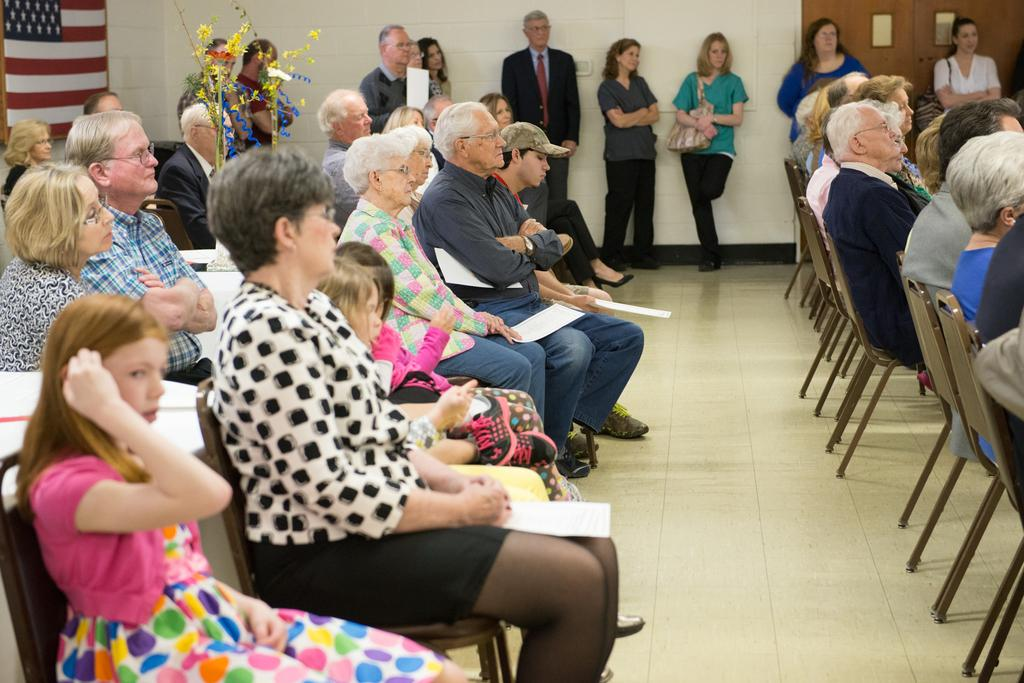What are the people in the image doing? There are people sitting on chairs and standing near a wall in the image. Can you describe the background of the image? There is an American flag in the background of the image. What type of music is the band playing in the image? There is no band present in the image, so it is not possible to determine what type of music they might be playing. 